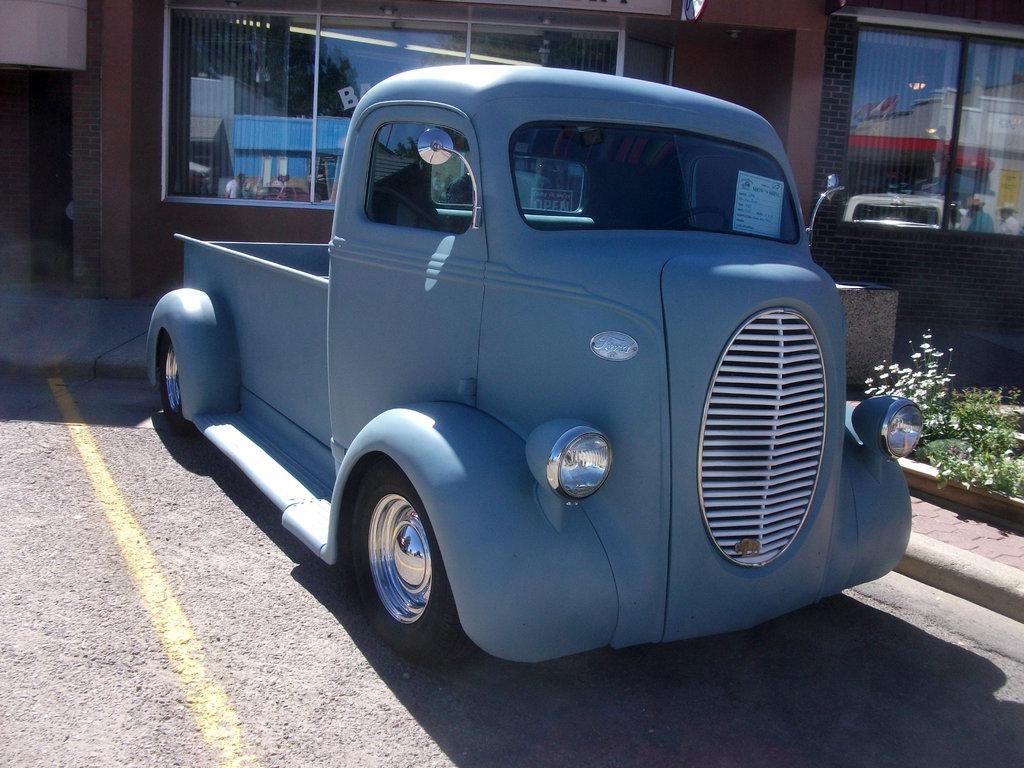Please provide a concise description of this image. This image consists of a vehicle in gray color parked on the road. At the bottom, there is a road. In the background, we can see a building. On the right, there are plants. 